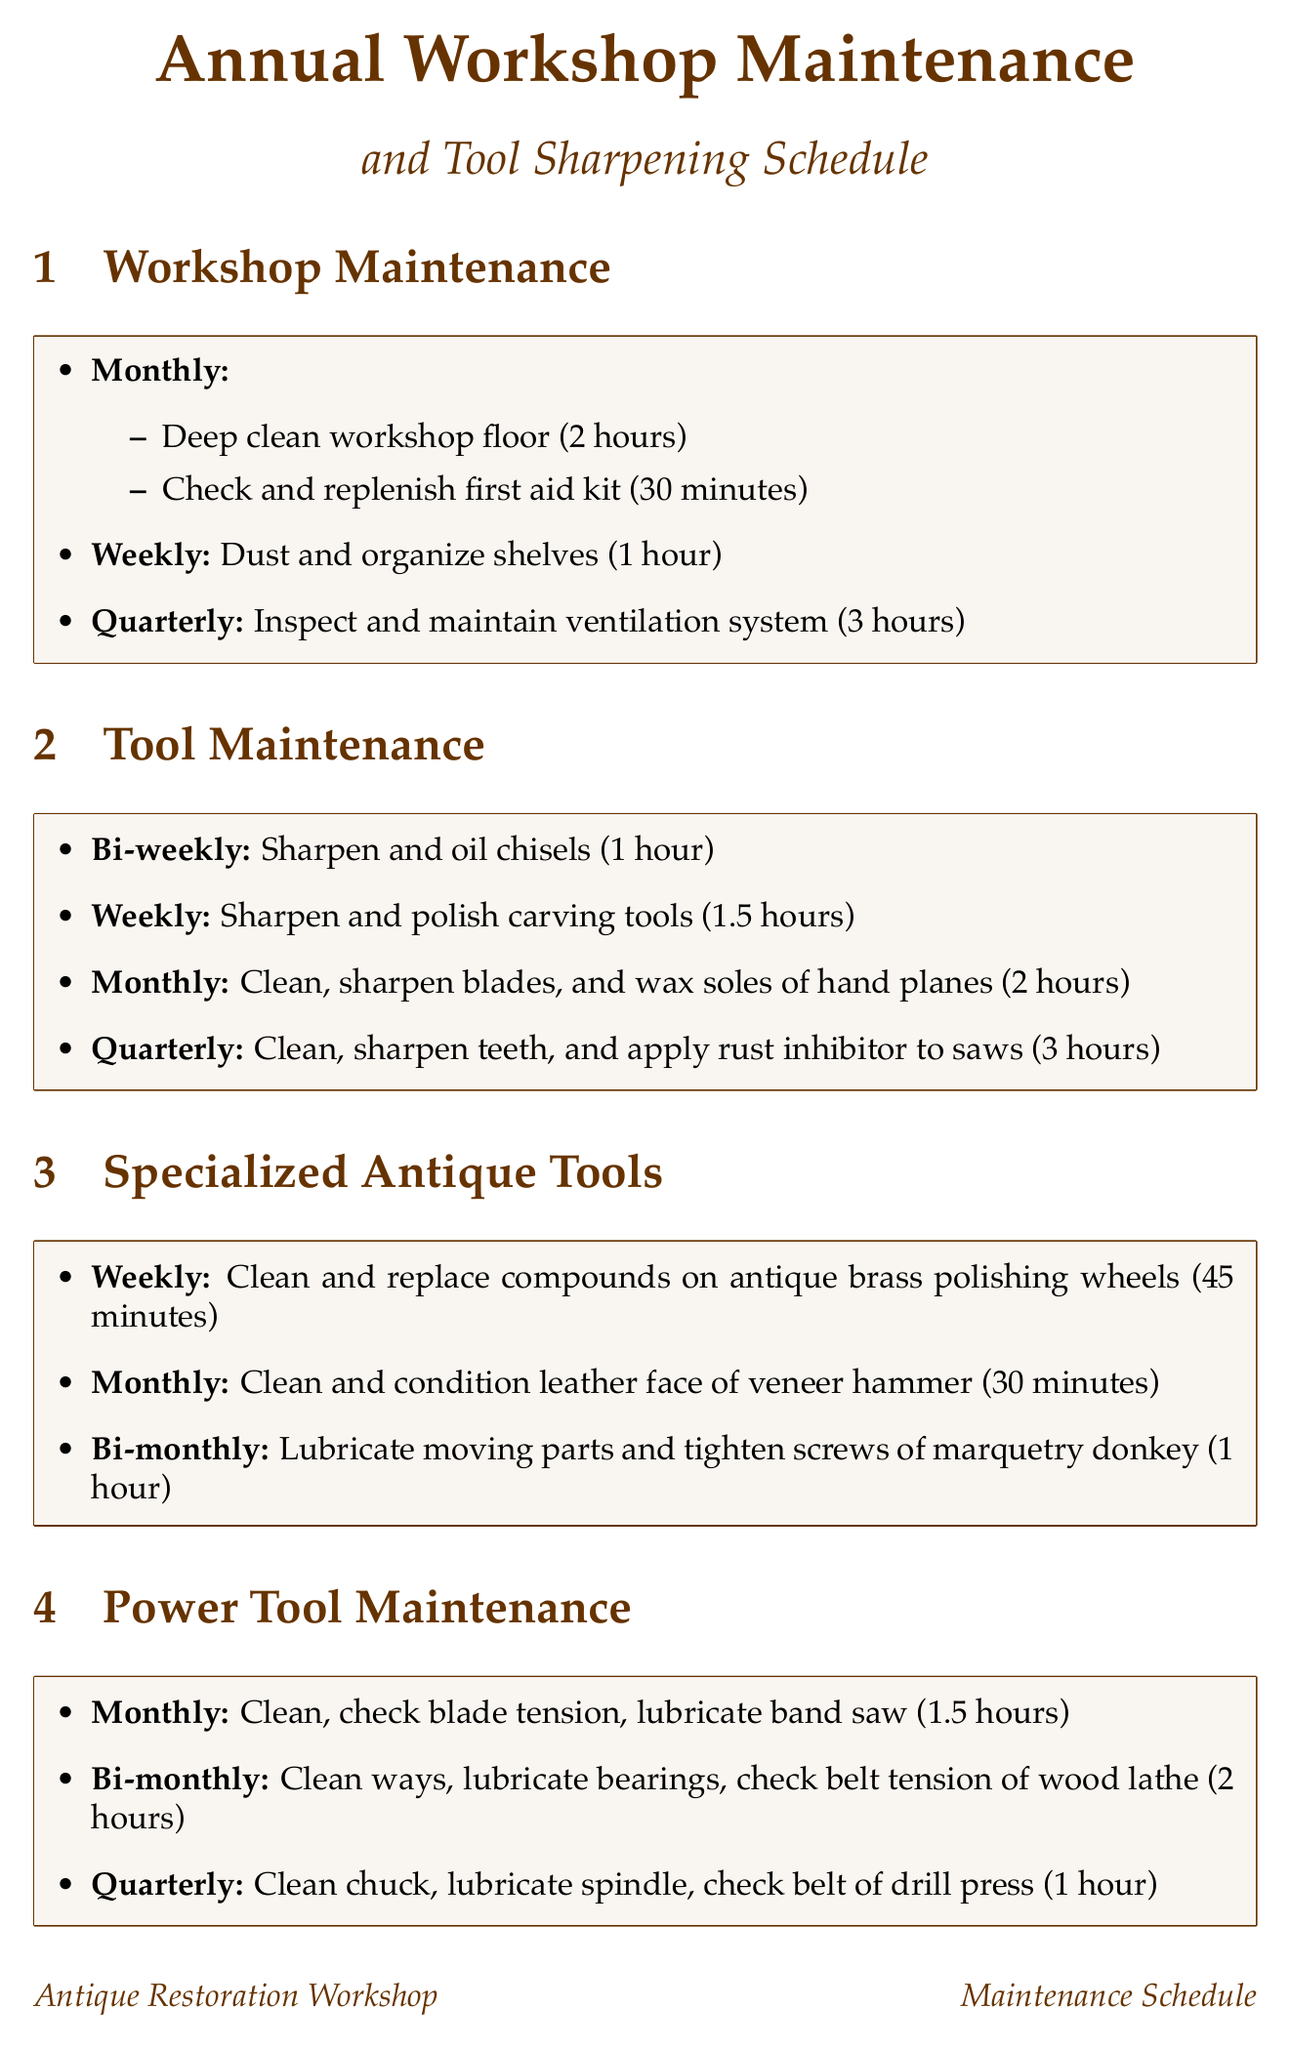What is the frequency for cleaning and organizing shelves? The frequency for this task is listed in the workshop maintenance section.
Answer: Weekly How long does it take to deep clean the workshop floor? The time required for this task is mentioned under workshop maintenance.
Answer: 2 hours What tool is sharpened and oiled bi-weekly? This specific tool can be found in the tool maintenance section.
Answer: Chisels What is the maintenance task for band saw? This information can be found under power tool maintenance.
Answer: Clean, check blade tension, lubricate How many days does the summer maintenance task take? The duration for this seasonal task is provided in the seasonal tasks section.
Answer: 3 days Which specialized antique tool is cleaned and conditioned monthly? This tool is mentioned in the specialized antique tools section.
Answer: Veneer hammer What do you do to saws quarterly? The maintenance task for saws is detailed in tool maintenance.
Answer: Clean, sharpen teeth, and apply rust inhibitor How often are the moving parts of the marquetry donkey lubricated? The frequency of this maintenance task is indicated in the specialized antique tools section.
Answer: Bi-monthly What is the purpose of the winter seasonal task? This information is included under seasonal tasks for winter.
Answer: Annual tool inventory and condition assessment 